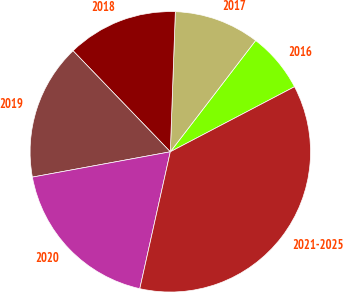Convert chart. <chart><loc_0><loc_0><loc_500><loc_500><pie_chart><fcel>2016<fcel>2017<fcel>2018<fcel>2019<fcel>2020<fcel>2021-2025<nl><fcel>6.91%<fcel>9.84%<fcel>12.77%<fcel>15.69%<fcel>18.62%<fcel>36.17%<nl></chart> 